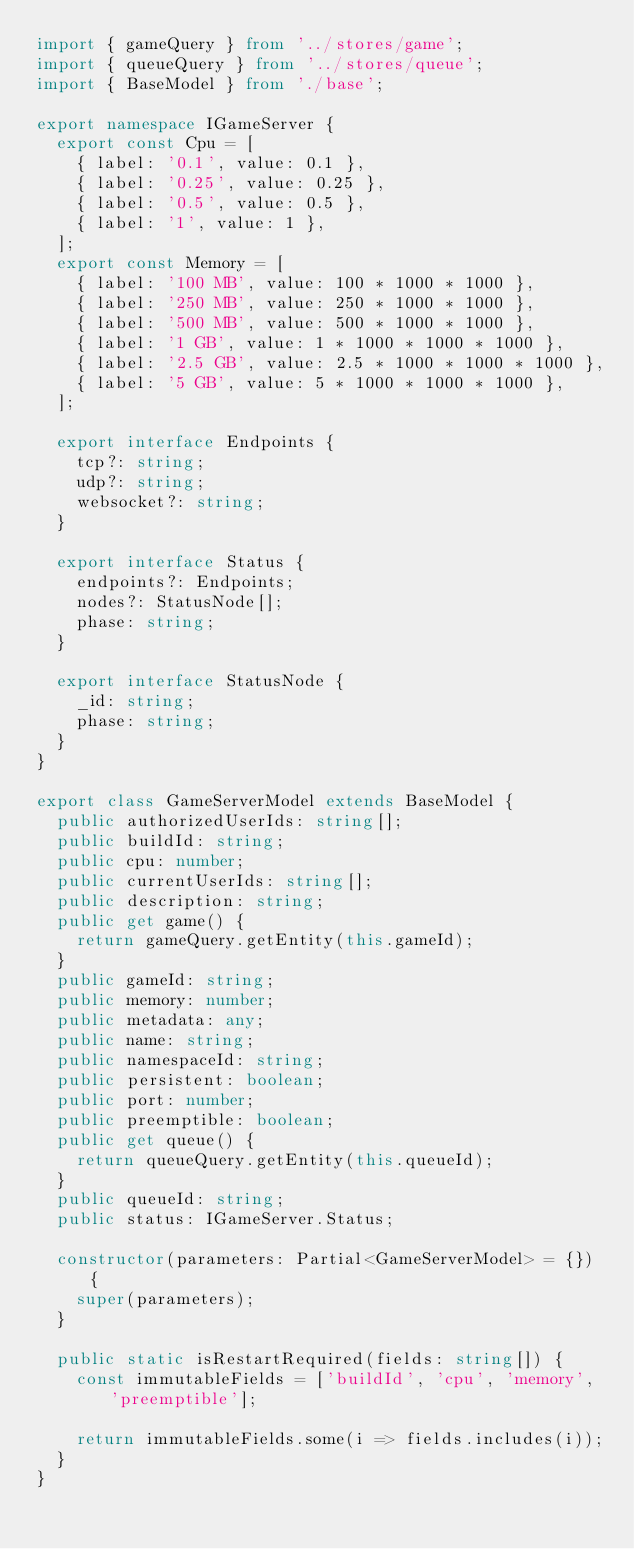<code> <loc_0><loc_0><loc_500><loc_500><_TypeScript_>import { gameQuery } from '../stores/game';
import { queueQuery } from '../stores/queue';
import { BaseModel } from './base';

export namespace IGameServer {
  export const Cpu = [
    { label: '0.1', value: 0.1 },
    { label: '0.25', value: 0.25 },
    { label: '0.5', value: 0.5 },
    { label: '1', value: 1 },
  ];
  export const Memory = [
    { label: '100 MB', value: 100 * 1000 * 1000 },
    { label: '250 MB', value: 250 * 1000 * 1000 },
    { label: '500 MB', value: 500 * 1000 * 1000 },
    { label: '1 GB', value: 1 * 1000 * 1000 * 1000 },
    { label: '2.5 GB', value: 2.5 * 1000 * 1000 * 1000 },
    { label: '5 GB', value: 5 * 1000 * 1000 * 1000 },
  ];

  export interface Endpoints {
    tcp?: string;
    udp?: string;
    websocket?: string;
  }

  export interface Status {
    endpoints?: Endpoints;
    nodes?: StatusNode[];
    phase: string;
  }

  export interface StatusNode {
    _id: string;
    phase: string;
  }
}

export class GameServerModel extends BaseModel {
  public authorizedUserIds: string[];
  public buildId: string;
  public cpu: number;
  public currentUserIds: string[];
  public description: string;
  public get game() {
    return gameQuery.getEntity(this.gameId);
  }
  public gameId: string;
  public memory: number;
  public metadata: any;
  public name: string;
  public namespaceId: string;
  public persistent: boolean;
  public port: number;
  public preemptible: boolean;
  public get queue() {
    return queueQuery.getEntity(this.queueId);
  }
  public queueId: string;
  public status: IGameServer.Status;

  constructor(parameters: Partial<GameServerModel> = {}) {
    super(parameters);
  }

  public static isRestartRequired(fields: string[]) {
    const immutableFields = ['buildId', 'cpu', 'memory', 'preemptible'];

    return immutableFields.some(i => fields.includes(i));
  }
}
</code> 